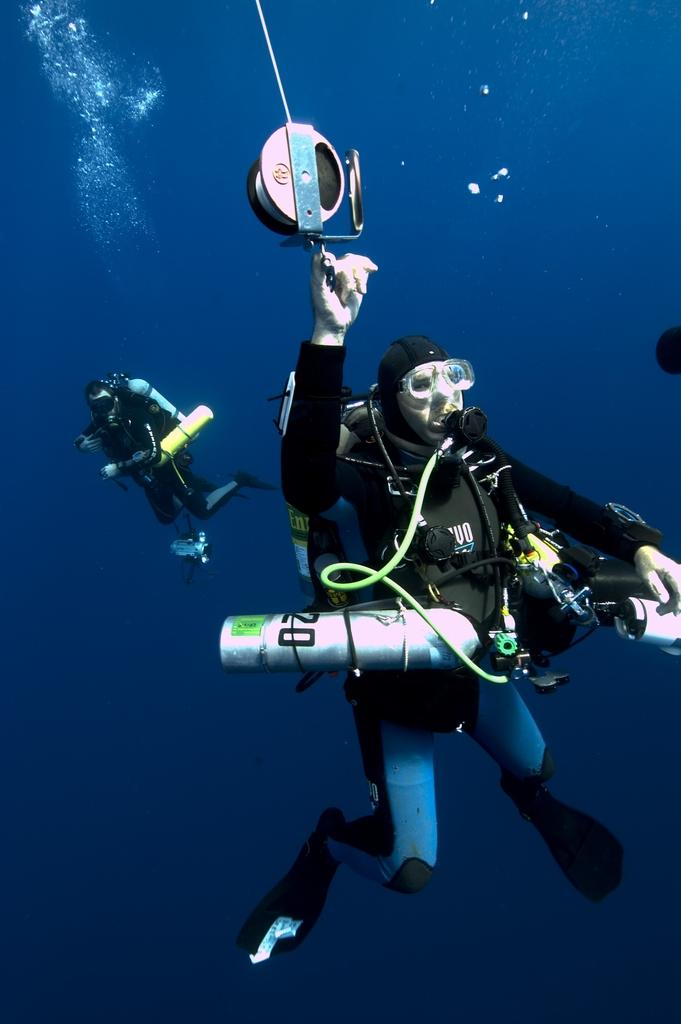What are the people in the image doing? The people in the image are swimming in the water. Can you describe the setting where the people are swimming? The setting is in the water, but the specific location is not mentioned in the facts. What type of haircut does the person in the water have? There is no information about the people's haircuts in the image. Is there a ring visible in the water? There is no mention of a ring in the image. 